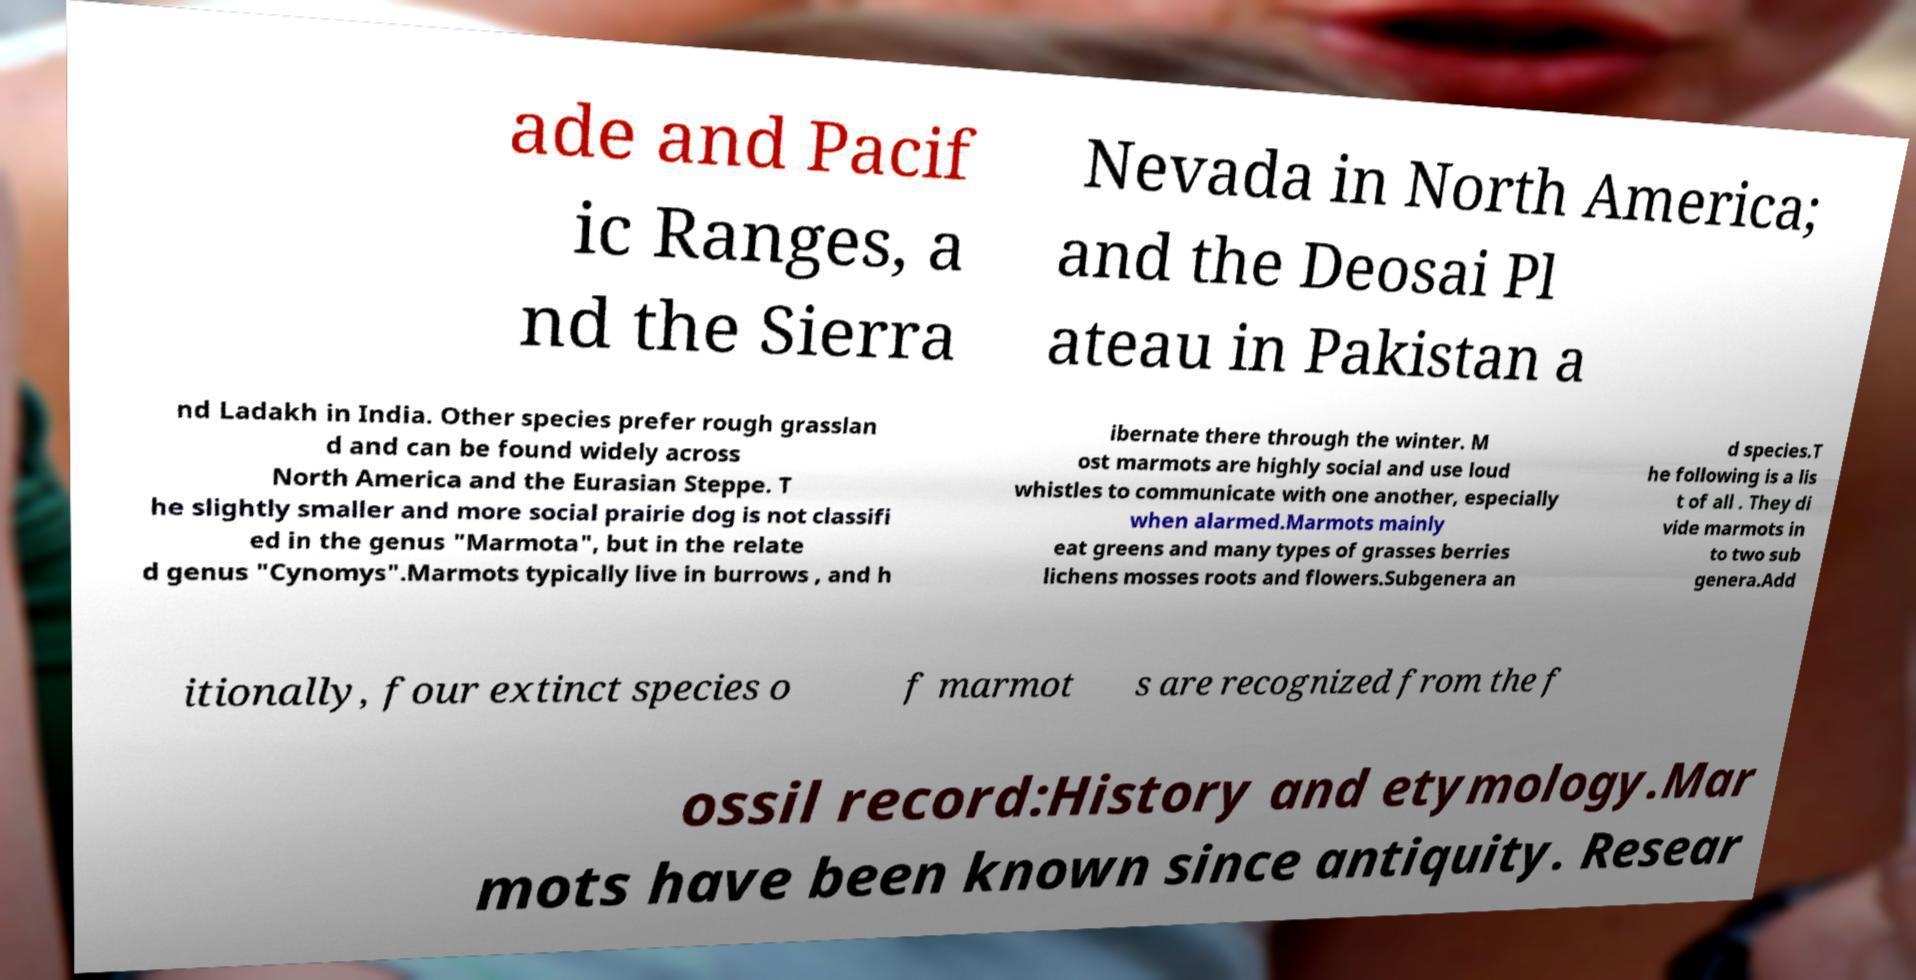There's text embedded in this image that I need extracted. Can you transcribe it verbatim? ade and Pacif ic Ranges, a nd the Sierra Nevada in North America; and the Deosai Pl ateau in Pakistan a nd Ladakh in India. Other species prefer rough grasslan d and can be found widely across North America and the Eurasian Steppe. T he slightly smaller and more social prairie dog is not classifi ed in the genus "Marmota", but in the relate d genus "Cynomys".Marmots typically live in burrows , and h ibernate there through the winter. M ost marmots are highly social and use loud whistles to communicate with one another, especially when alarmed.Marmots mainly eat greens and many types of grasses berries lichens mosses roots and flowers.Subgenera an d species.T he following is a lis t of all . They di vide marmots in to two sub genera.Add itionally, four extinct species o f marmot s are recognized from the f ossil record:History and etymology.Mar mots have been known since antiquity. Resear 